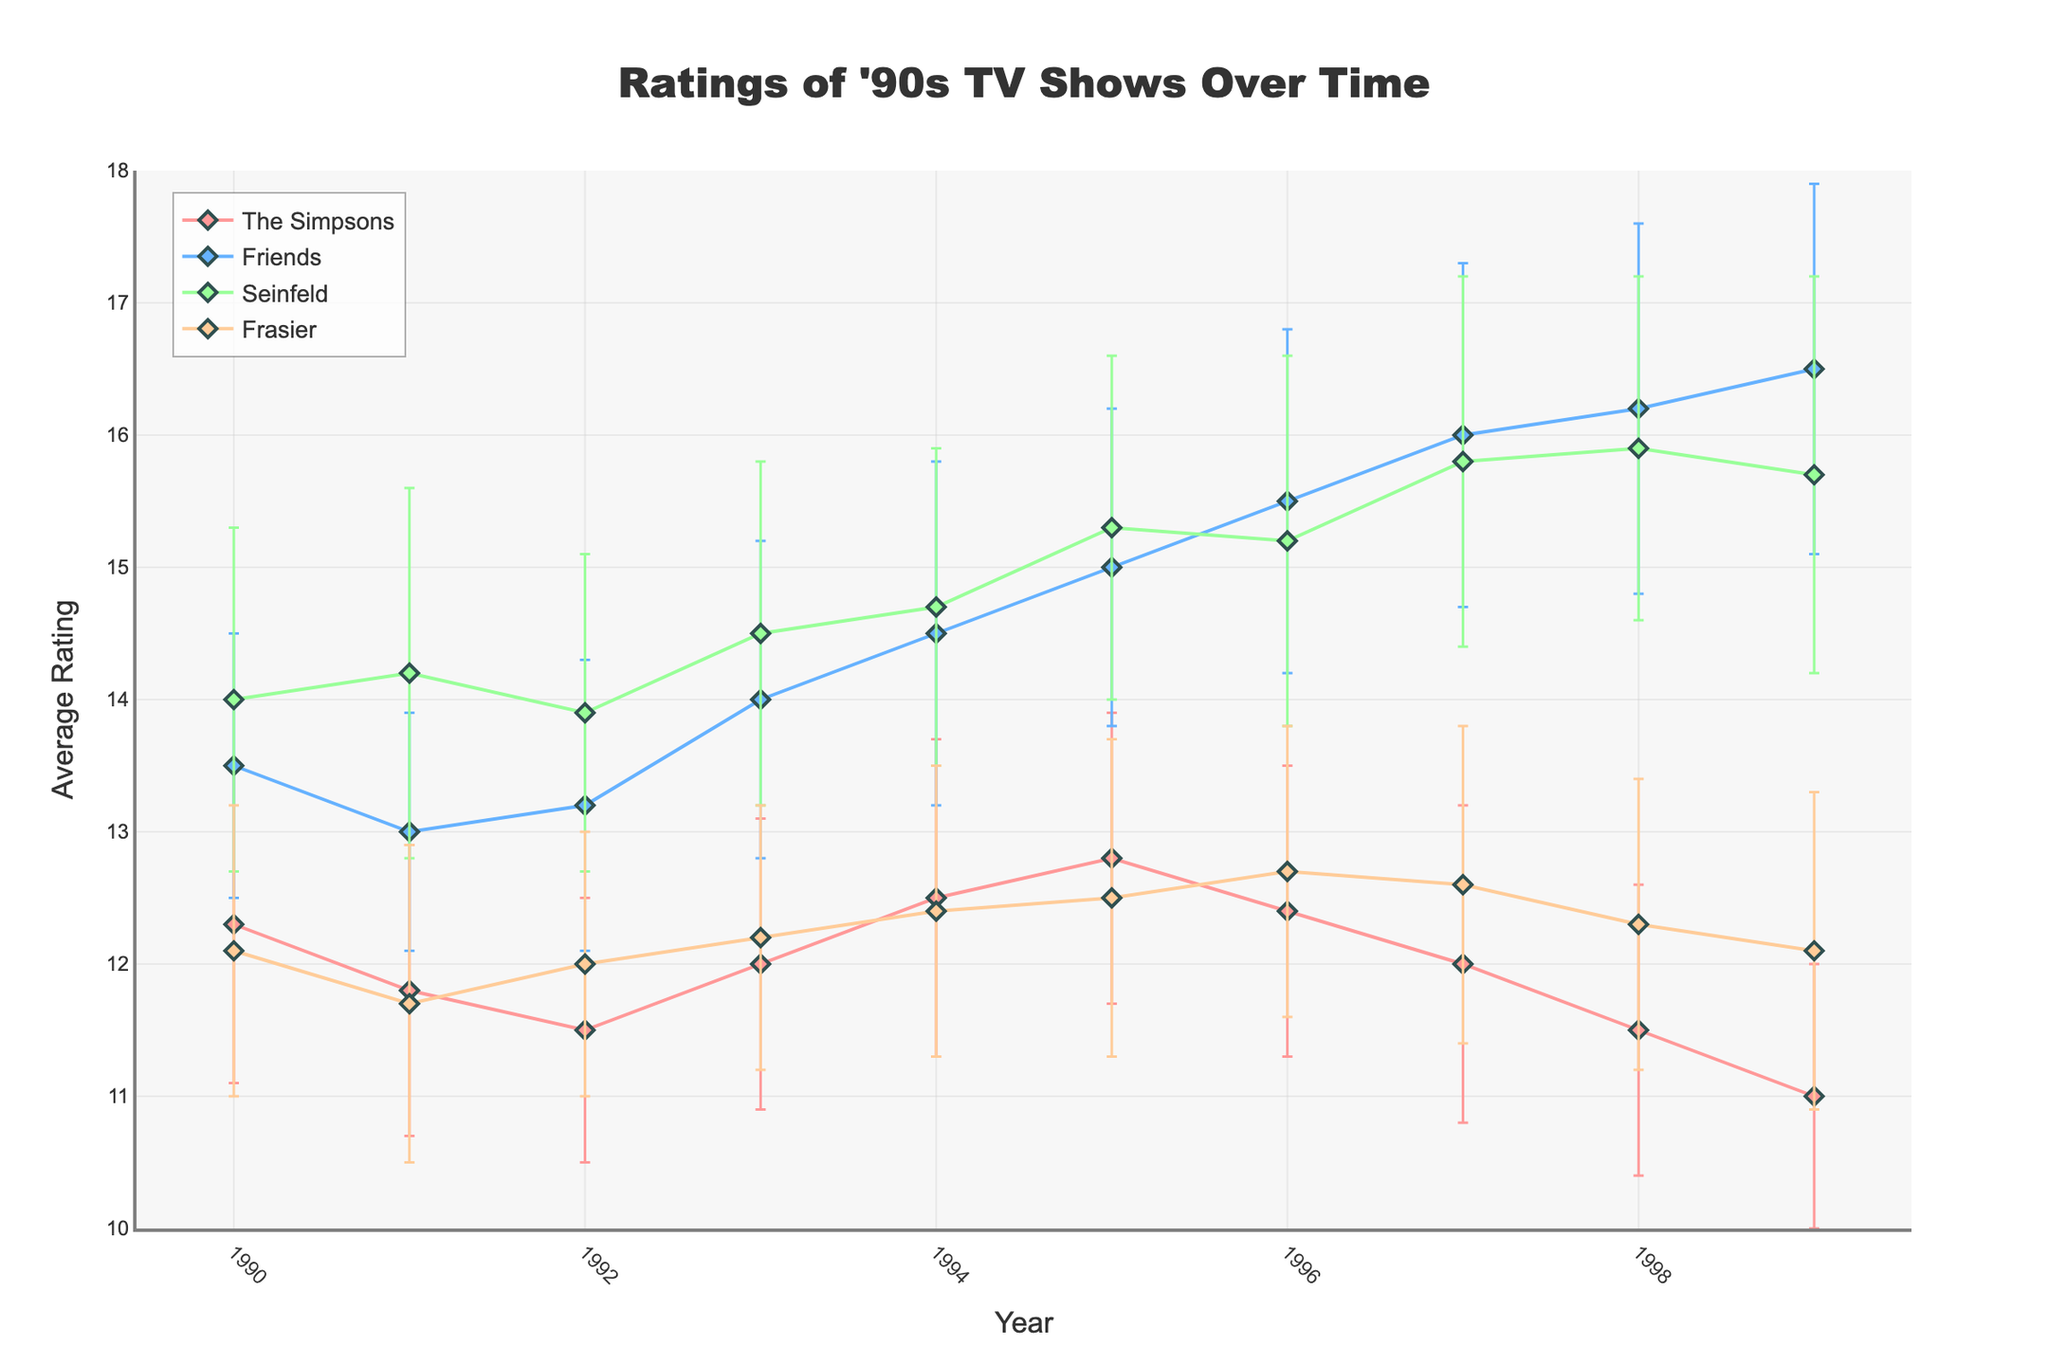What's the title of the plot? The title of the plot is visible at the top center of the figure, typically in a larger and bolder font.
Answer: Ratings of '90s TV Shows Over Time How many shows are represented in the figure? There are four distinct lines or markers in the plot, each representing a different TV show.
Answer: Four Which show had the highest average rating in 1990? In 1990, the plot shows the data points for each show. By examining the vertical position, we can see that Seinfeld has the highest rating.
Answer: Seinfeld Which show had the highest rating in 1999, and what was the rating? By examining the data points for 1999, the highest vertical position corresponds to Friends with a rating of 16.5.
Answer: Friends, 16.5 Between which years did the average rating for The Simpsons decrease the most? By following the line for The Simpsons over the years, the sharpest decline occurs between 1997 and 1999.
Answer: 1997 and 1999 What was Frasier's average rating in 1995, and how does it compare to 1994? Frasier's rating in 1995 was 12.5, while in 1994, it was 12.4. The difference is 0.1.
Answer: 12.5, 0.1 higher than 1994 On average, which show had the most consistent viewer count from 1990 to 1999? By examining the error bars, Friends generally have the smallest standard deviations over the years, indicating less variability in viewer counts.
Answer: Friends Which show had the highest variability in viewer count in 1991? The standard deviations are indicated by the length of the error bars. In 1991, Seinfeld has the longest error bars, indicating the highest variability.
Answer: Seinfeld Did any show have an increasing trend in their average rating from 1990 to 1999? By following the lines for each show, Friends show a generally increasing trend in their average rating from 1990 to 1999.
Answer: Friends 